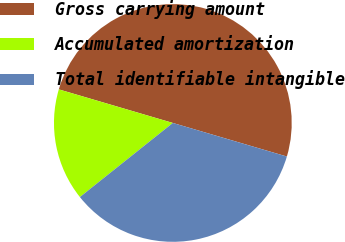Convert chart. <chart><loc_0><loc_0><loc_500><loc_500><pie_chart><fcel>Gross carrying amount<fcel>Accumulated amortization<fcel>Total identifiable intangible<nl><fcel>50.0%<fcel>15.27%<fcel>34.73%<nl></chart> 